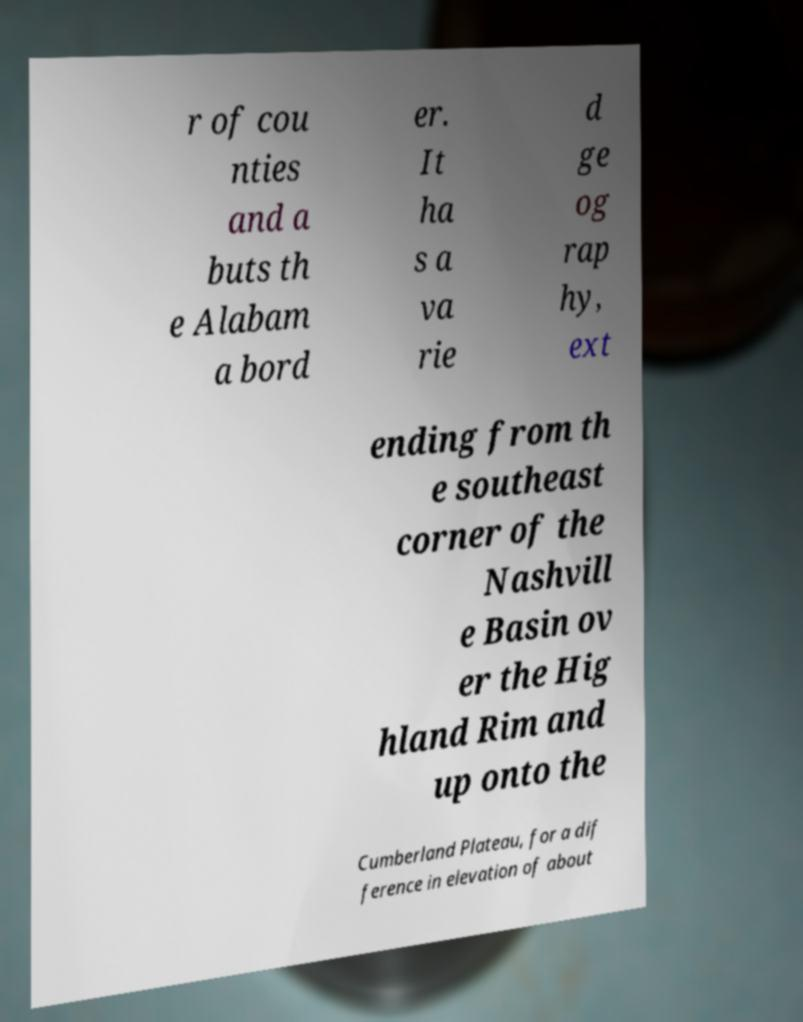There's text embedded in this image that I need extracted. Can you transcribe it verbatim? r of cou nties and a buts th e Alabam a bord er. It ha s a va rie d ge og rap hy, ext ending from th e southeast corner of the Nashvill e Basin ov er the Hig hland Rim and up onto the Cumberland Plateau, for a dif ference in elevation of about 